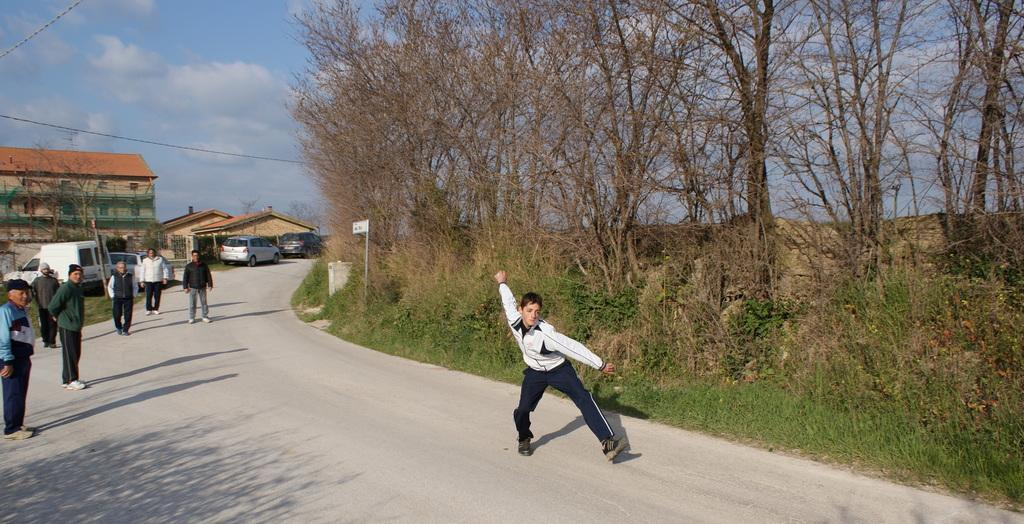What can be seen on the road in the image? There are persons on the road in the image. What else is present in the image besides the persons on the road? There are vehicles, poles, boards, grass, plants, trees, houses, and the sky visible in the background. Can you describe the sky in the image? The sky is visible in the background, and there are clouds in the sky. What type of manager is responsible for the clouds in the image? There is no manager present in the image, and the clouds are a natural weather phenomenon. How does the image affect the sleep of the persons on the road? The image itself does not have any direct effect on the sleep of the persons on the road; it is a static representation. 